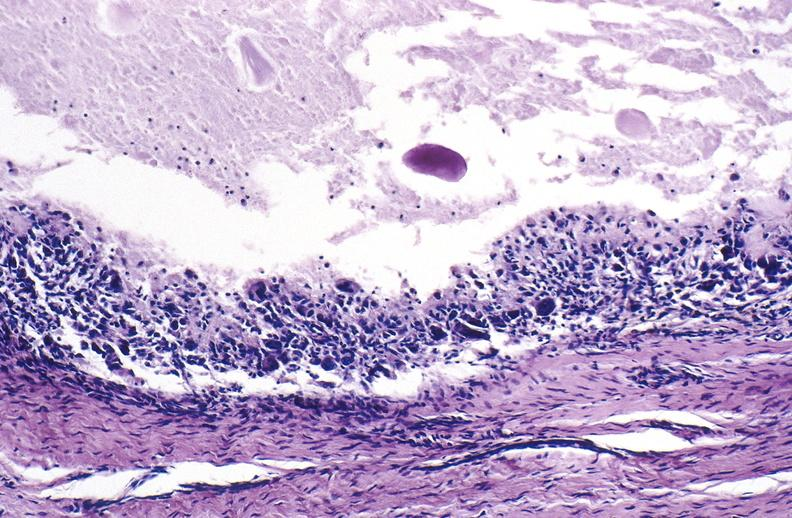does this image show gout?
Answer the question using a single word or phrase. Yes 